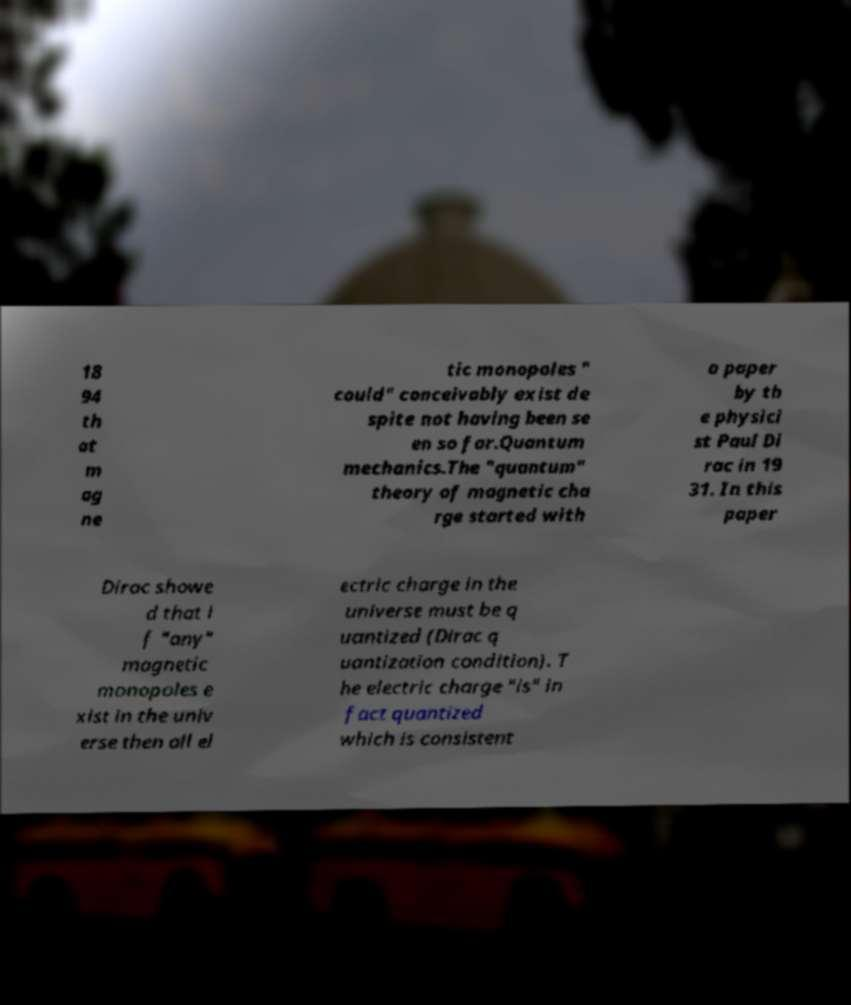For documentation purposes, I need the text within this image transcribed. Could you provide that? 18 94 th at m ag ne tic monopoles " could" conceivably exist de spite not having been se en so far.Quantum mechanics.The "quantum" theory of magnetic cha rge started with a paper by th e physici st Paul Di rac in 19 31. In this paper Dirac showe d that i f "any" magnetic monopoles e xist in the univ erse then all el ectric charge in the universe must be q uantized (Dirac q uantization condition). T he electric charge "is" in fact quantized which is consistent 